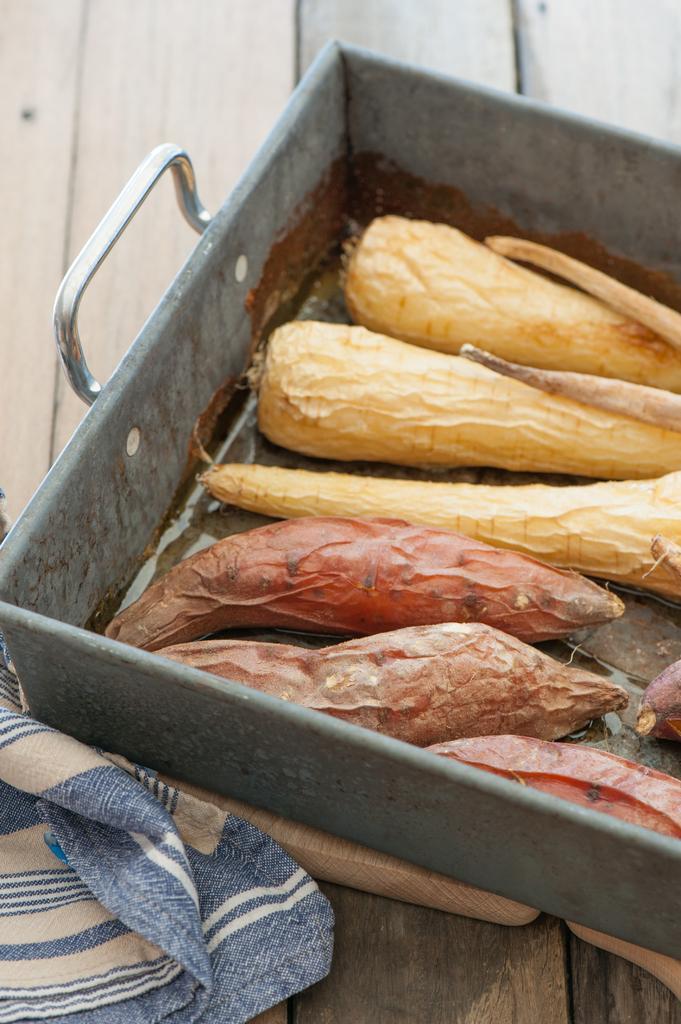How would you summarize this image in a sentence or two? In this image there is a tray and a cloth on a wooden table. In the tray there are vegetables. At the top there is a wooden wall. 